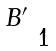Convert formula to latex. <formula><loc_0><loc_0><loc_500><loc_500>\begin{smallmatrix} B ^ { \prime } & \\ & 1 \end{smallmatrix}</formula> 